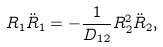Convert formula to latex. <formula><loc_0><loc_0><loc_500><loc_500>R _ { 1 } \ddot { R } _ { 1 } = - \frac { 1 } { D _ { 1 2 } } R _ { 2 } ^ { 2 } \ddot { R } _ { 2 } ,</formula> 